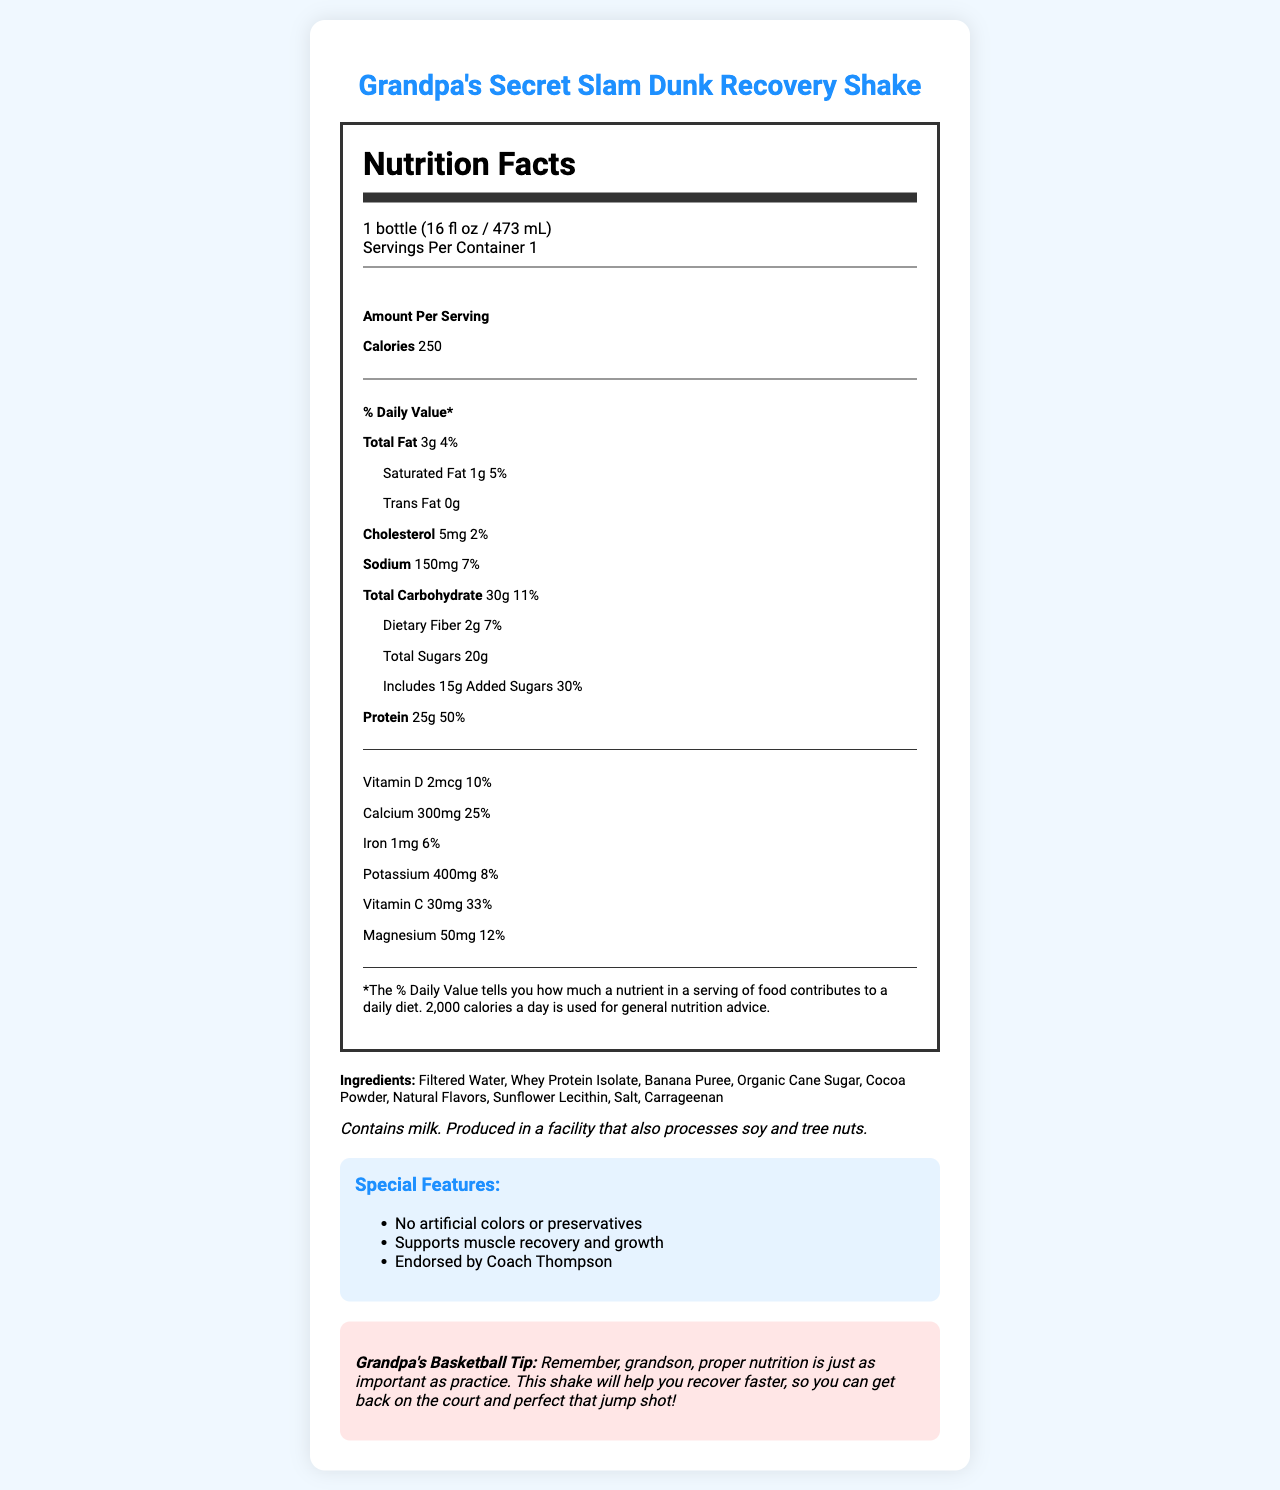what is the serving size of Grandpa's Secret Slam Dunk Recovery Shake? The label clearly states that the serving size is 1 bottle or 16 fluid ounces (473 mL).
Answer: 1 bottle (16 fl oz / 473 mL) how many calories are in one serving of the shake? The document mentions that one serving of the shake contains 250 calories.
Answer: 250 calories what is the percentage of daily value for protein in the shake? The label indicates the shake provides 25 grams of protein, which is 50% of the daily value.
Answer: 50% how much potassium is in the shake? The nutrition information section shows that the shake contains 400 mg of potassium, which is 8% of the daily value.
Answer: 400 mg what allergens are mentioned in the shake's ingredient list? The allergen information notes that the shake contains milk.
Answer: Milk Which vitamin has the highest percentage of daily value in the shake? A. Vitamin D B. Calcium C. Vitamin C D. Iron The label indicates Vitamin C has a 33% daily value, which is the highest among the listed vitamins and minerals.
Answer: C. Vitamin C Grandpa's shake supports muscle recovery, but which special feature is NOT mentioned? A. No artificial colors B. No artificial preservatives C. Endorsed by Coach Thompson D. Low calorie The special features listed are "No artificial colors or preservatives" and "Endorsed by Coach Thompson." "Low calorie" is not mentioned.
Answer: D. Low calorie Is the shake suitable for someone with a soy allergy? The label warns that the shake is produced in a facility that processes soy, so there is a risk of cross-contamination.
Answer: No summarize the main purpose of Grandpa's Secret Slam Dunk Recovery Shake based on the document. The document highlights the nutritional benefits, special features, and endorsement of the shake, emphasizing its role in post-workout recovery and muscle growth.
Answer: The shake is designed to support muscle recovery and growth with 25 grams of protein, along with several vitamins and minerals. It contains no artificial colors or preservatives and is endorsed by Coach Thompson. It's a nutritious post-workout option with a focus on aiding recovery. What is the total amount of sugar in the shake, including added sugars? The label specifies there are 20 grams of total sugars, which includes 15 grams of added sugars.
Answer: 20g total sugars, with 15g added sugars how many servings are in one container of the shake? The document clearly indicates that there is 1 serving per container.
Answer: 1 serving how many grams of saturated fat are in the shake? The nutrition label shows that the shake contains 1 gram of saturated fat.
Answer: 1g what is the role of carrageenan in the shake? The document lists carrageenan as an ingredient but does not specify its role.
Answer: Cannot be determined 